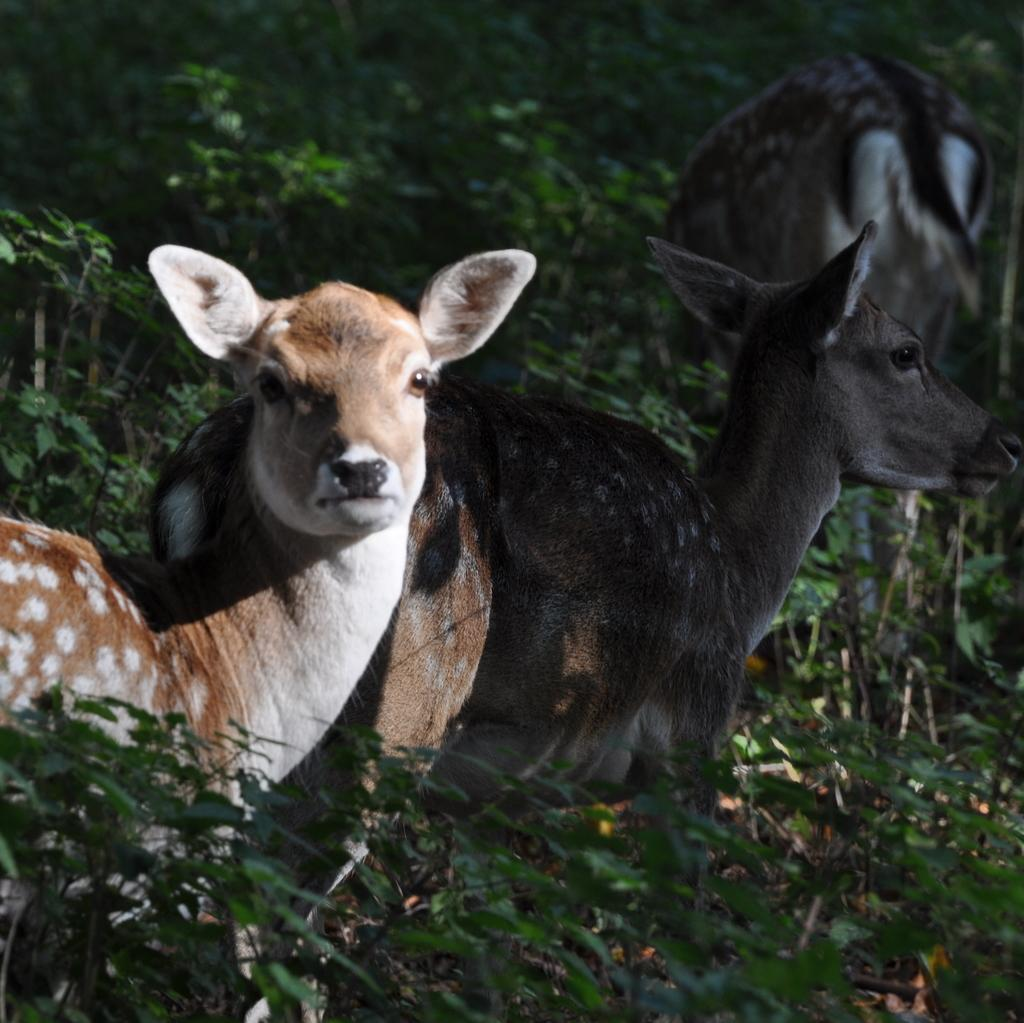How many deers are present in the image? There are three deers in the image. What is located around the deers? There is a group of plants around the deers. Reasoning: Leting: Let's think step by step in order to produce the conversation. We start by identifying the main subjects in the image, which are the three deers. Then, we describe the surrounding environment by mentioning the group of plants. Each question is designed to elicit a specific detail about the image that is known from the provided facts. Absurd Question/Answer: What type of waste can be seen being divided among the deers in the image? There is no waste or division present in the image; it features three deers and a group of plants. What type of division is occurring among the plants in the image? There is no division occurring among the plants in the image; it features three deers and a group of plants. 